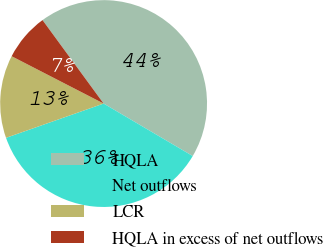<chart> <loc_0><loc_0><loc_500><loc_500><pie_chart><fcel>HQLA<fcel>Net outflows<fcel>LCR<fcel>HQLA in excess of net outflows<nl><fcel>43.53%<fcel>36.15%<fcel>12.94%<fcel>7.38%<nl></chart> 